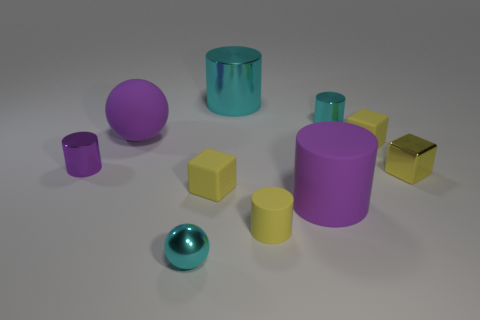Subtract all yellow cubes. How many were subtracted if there are1yellow cubes left? 2 Subtract all yellow cylinders. How many cylinders are left? 4 Subtract all large shiny cylinders. How many cylinders are left? 4 Subtract all yellow cylinders. Subtract all blue spheres. How many cylinders are left? 4 Subtract all balls. How many objects are left? 8 Add 9 big brown matte cylinders. How many big brown matte cylinders exist? 9 Subtract 0 green balls. How many objects are left? 10 Subtract all large purple matte cylinders. Subtract all large cyan objects. How many objects are left? 8 Add 6 yellow objects. How many yellow objects are left? 10 